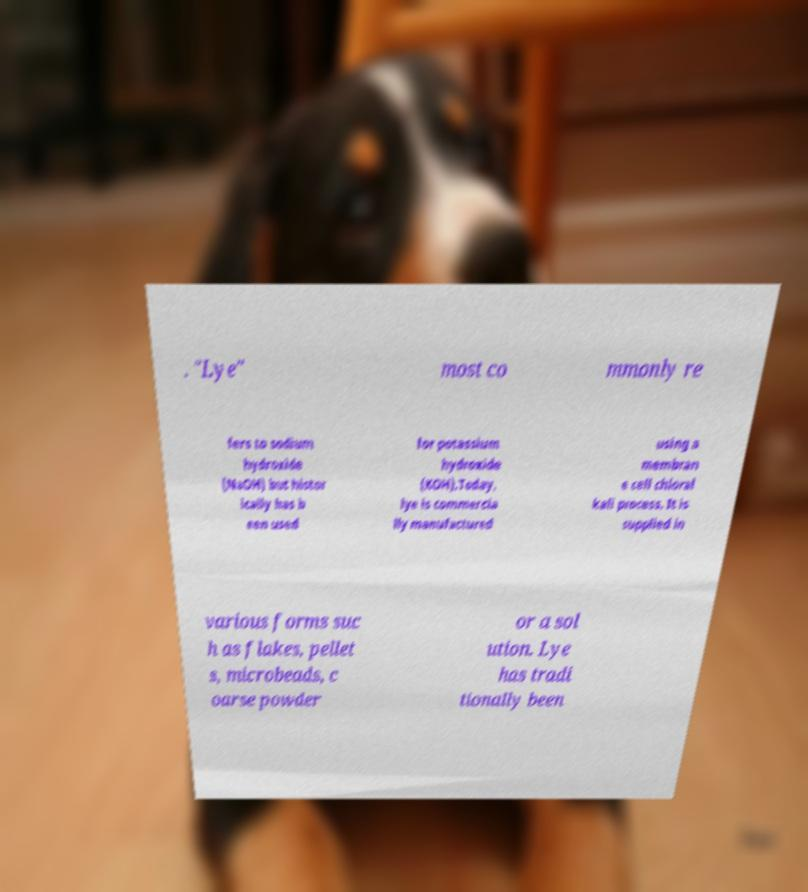What messages or text are displayed in this image? I need them in a readable, typed format. . "Lye" most co mmonly re fers to sodium hydroxide (NaOH) but histor ically has b een used for potassium hydroxide (KOH).Today, lye is commercia lly manufactured using a membran e cell chloral kali process. It is supplied in various forms suc h as flakes, pellet s, microbeads, c oarse powder or a sol ution. Lye has tradi tionally been 